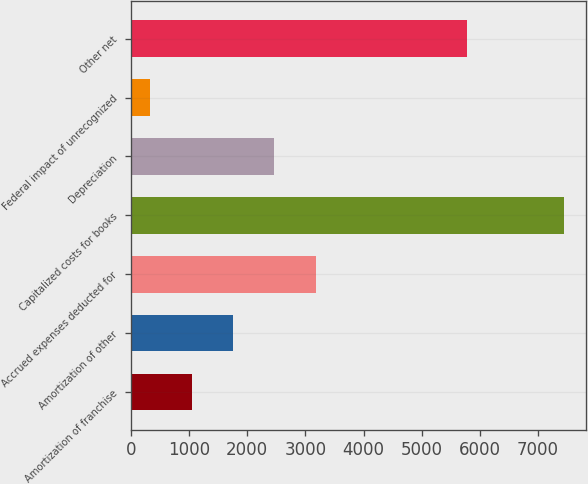Convert chart. <chart><loc_0><loc_0><loc_500><loc_500><bar_chart><fcel>Amortization of franchise<fcel>Amortization of other<fcel>Accrued expenses deducted for<fcel>Capitalized costs for books<fcel>Depreciation<fcel>Federal impact of unrecognized<fcel>Other net<nl><fcel>1042.7<fcel>1754.4<fcel>3177.8<fcel>7448<fcel>2466.1<fcel>331<fcel>5787<nl></chart> 